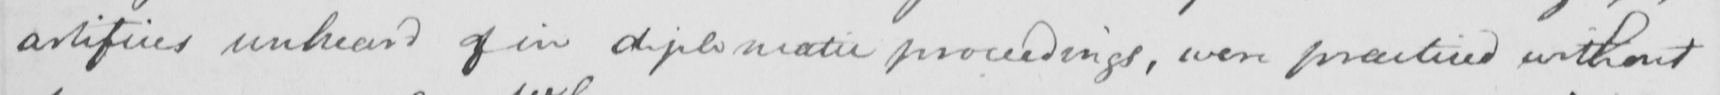What does this handwritten line say? artifices unheard of in diplomatic proceedings , even practiced without 